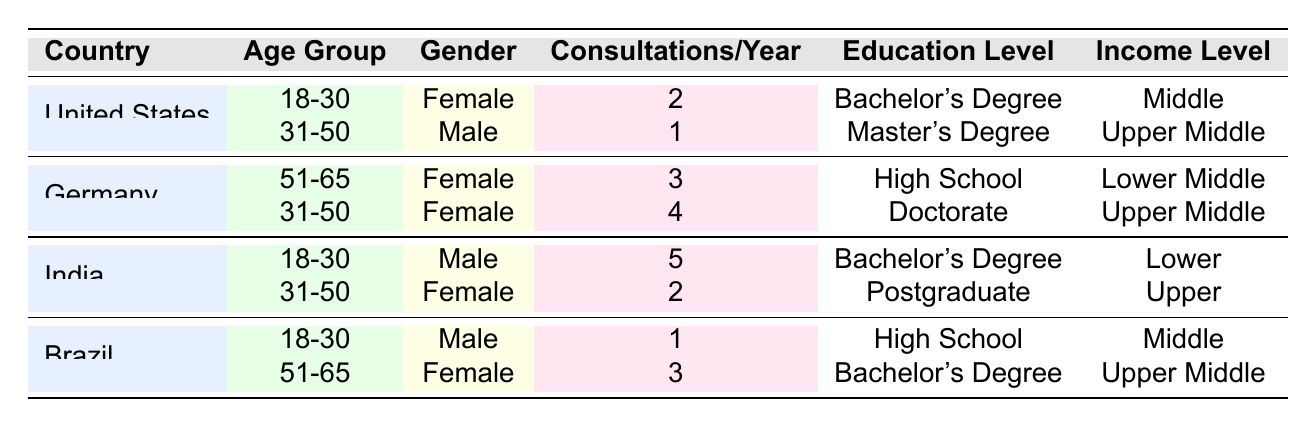What is the frequency of homeopathic consultations for females in the United States aged 18-30? The table shows that in the United States, the 18-30 age group for females has a consultation frequency of 2 times per year.
Answer: 2 How many homeopathic consultations do females in India aged 31-50 have per year? Referring to the table, females in India aged 31-50 have 2 consultations per year.
Answer: 2 Which country has the highest frequency of homeopathic consultations for males aged 18-30? The data indicates that males in India aged 18-30 have the highest consultation frequency of 5 times per year compared to other countries.
Answer: India What is the average consultation frequency for males across all age groups in the table? The consultation frequencies for males are 5 (India, 18-30) and 1 (Brazil, 18-30; United States, 31-50). Summing these gives: 5 + 1 + 1 = 7. Divided by 3 males gives an average of 7/3 which is approximately 2.33.
Answer: 2.33 Is there a gender difference in homeopathic consultation frequency among the age group 31-50 in Germany? Yes, in Germany, males have a consultation frequency (1) that is lower than females (4) in the age group 31-50, indicating a significant gender difference.
Answer: Yes Which age group and gender combination has the highest number of homeopathic consultations in the table? Looking at the data, males in India aged 18-30 have the highest frequency with 5 consultations per year. This is more than any other demographic.
Answer: Males, India, 18-30 How many homeopathic consultations do females in Germany aged 51-65 have compared to males in Brazil aged 18-30? The frequency for females in Germany aged 51-65 is 3, while for males in Brazil aged 18-30 it is 1. Therefore, females in Germany have 2 more consultations than males in Brazil.
Answer: 2 more Are there any respondents with a doctorate education level who have a consultation frequency of less than 3? By examining the table, the only doctorate holder is the female in Germany aged 31-50 with a consultation frequency of 4, indicating no respondents with a doctorate have fewer consultations than 3.
Answer: No What is the total consultation frequency for females across all countries in the age group 51-65? Summing the consultation frequencies for females in the age group 51-65: 3 (Germany) + 3 (Brazil) = 6. Therefore, the total frequency for this demographic is 6 consultations per year.
Answer: 6 